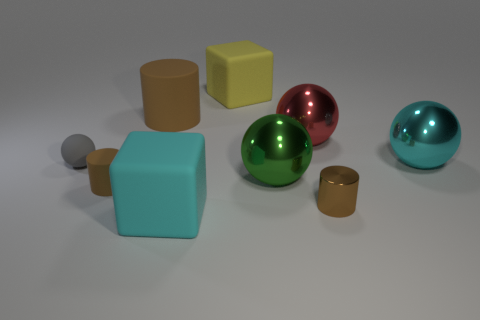What number of yellow objects are small objects or shiny objects? In the image, there is one yellow object, which is a small cube. There are no shiny yellow objects, as the shiny objects appear to be spheres and are not yellow. So, the number of yellow objects that are either small or shiny is one. 